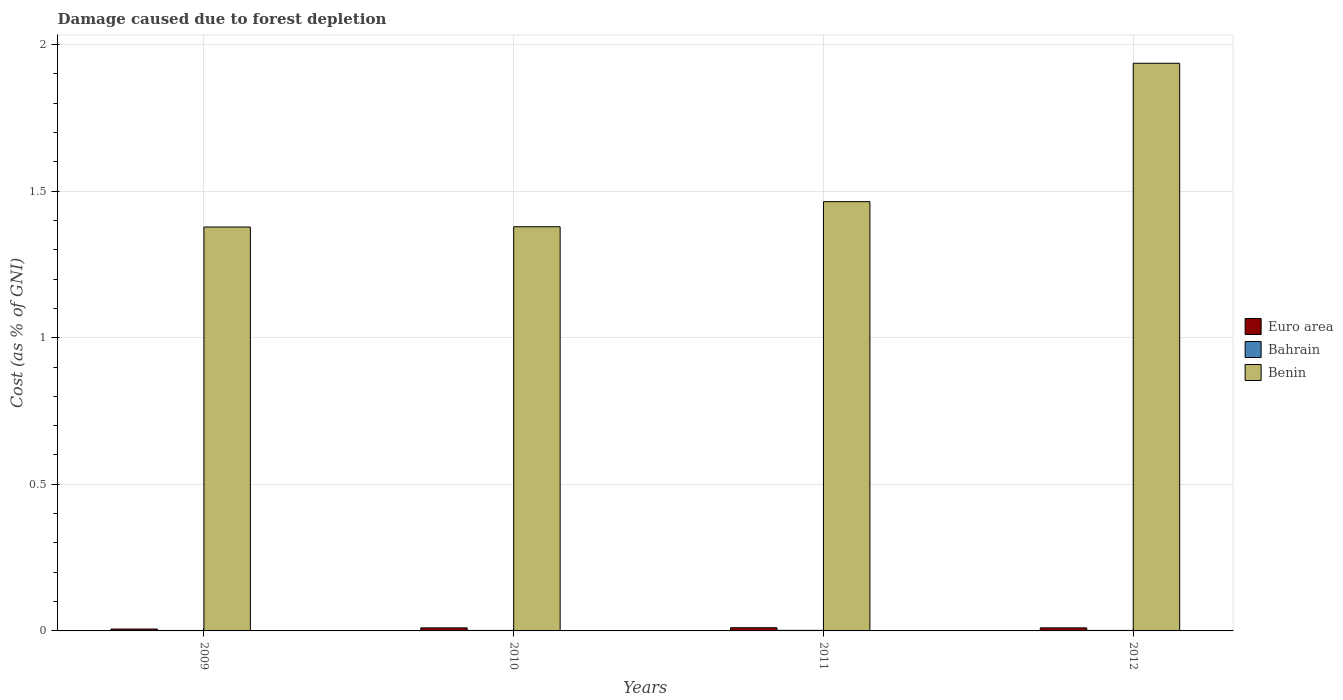How many different coloured bars are there?
Give a very brief answer. 3. How many groups of bars are there?
Your answer should be compact. 4. What is the label of the 2nd group of bars from the left?
Provide a short and direct response. 2010. What is the cost of damage caused due to forest depletion in Euro area in 2012?
Your answer should be compact. 0.01. Across all years, what is the maximum cost of damage caused due to forest depletion in Benin?
Provide a succinct answer. 1.94. Across all years, what is the minimum cost of damage caused due to forest depletion in Euro area?
Your answer should be very brief. 0.01. In which year was the cost of damage caused due to forest depletion in Euro area minimum?
Provide a succinct answer. 2009. What is the total cost of damage caused due to forest depletion in Euro area in the graph?
Your answer should be very brief. 0.04. What is the difference between the cost of damage caused due to forest depletion in Benin in 2009 and that in 2012?
Provide a short and direct response. -0.56. What is the difference between the cost of damage caused due to forest depletion in Benin in 2011 and the cost of damage caused due to forest depletion in Euro area in 2009?
Offer a very short reply. 1.46. What is the average cost of damage caused due to forest depletion in Bahrain per year?
Offer a terse response. 0. In the year 2012, what is the difference between the cost of damage caused due to forest depletion in Euro area and cost of damage caused due to forest depletion in Benin?
Make the answer very short. -1.93. In how many years, is the cost of damage caused due to forest depletion in Euro area greater than 1.6 %?
Offer a terse response. 0. What is the ratio of the cost of damage caused due to forest depletion in Benin in 2010 to that in 2012?
Give a very brief answer. 0.71. Is the difference between the cost of damage caused due to forest depletion in Euro area in 2011 and 2012 greater than the difference between the cost of damage caused due to forest depletion in Benin in 2011 and 2012?
Give a very brief answer. Yes. What is the difference between the highest and the second highest cost of damage caused due to forest depletion in Bahrain?
Provide a short and direct response. 0. What is the difference between the highest and the lowest cost of damage caused due to forest depletion in Bahrain?
Your answer should be compact. 0. What does the 2nd bar from the left in 2009 represents?
Keep it short and to the point. Bahrain. What does the 2nd bar from the right in 2011 represents?
Provide a succinct answer. Bahrain. Are the values on the major ticks of Y-axis written in scientific E-notation?
Your answer should be very brief. No. How many legend labels are there?
Offer a very short reply. 3. How are the legend labels stacked?
Ensure brevity in your answer.  Vertical. What is the title of the graph?
Provide a succinct answer. Damage caused due to forest depletion. Does "Jordan" appear as one of the legend labels in the graph?
Your answer should be compact. No. What is the label or title of the Y-axis?
Provide a succinct answer. Cost (as % of GNI). What is the Cost (as % of GNI) of Euro area in 2009?
Your answer should be very brief. 0.01. What is the Cost (as % of GNI) in Bahrain in 2009?
Provide a succinct answer. 0. What is the Cost (as % of GNI) in Benin in 2009?
Provide a succinct answer. 1.38. What is the Cost (as % of GNI) of Euro area in 2010?
Give a very brief answer. 0.01. What is the Cost (as % of GNI) in Bahrain in 2010?
Provide a succinct answer. 0. What is the Cost (as % of GNI) in Benin in 2010?
Ensure brevity in your answer.  1.38. What is the Cost (as % of GNI) in Euro area in 2011?
Your response must be concise. 0.01. What is the Cost (as % of GNI) of Bahrain in 2011?
Ensure brevity in your answer.  0. What is the Cost (as % of GNI) in Benin in 2011?
Provide a short and direct response. 1.46. What is the Cost (as % of GNI) in Euro area in 2012?
Give a very brief answer. 0.01. What is the Cost (as % of GNI) in Bahrain in 2012?
Your response must be concise. 0. What is the Cost (as % of GNI) of Benin in 2012?
Give a very brief answer. 1.94. Across all years, what is the maximum Cost (as % of GNI) in Euro area?
Provide a succinct answer. 0.01. Across all years, what is the maximum Cost (as % of GNI) in Bahrain?
Your answer should be compact. 0. Across all years, what is the maximum Cost (as % of GNI) in Benin?
Your answer should be very brief. 1.94. Across all years, what is the minimum Cost (as % of GNI) in Euro area?
Your answer should be very brief. 0.01. Across all years, what is the minimum Cost (as % of GNI) in Bahrain?
Make the answer very short. 0. Across all years, what is the minimum Cost (as % of GNI) in Benin?
Offer a very short reply. 1.38. What is the total Cost (as % of GNI) in Euro area in the graph?
Your answer should be compact. 0.04. What is the total Cost (as % of GNI) of Bahrain in the graph?
Give a very brief answer. 0.01. What is the total Cost (as % of GNI) of Benin in the graph?
Provide a short and direct response. 6.16. What is the difference between the Cost (as % of GNI) of Euro area in 2009 and that in 2010?
Provide a succinct answer. -0. What is the difference between the Cost (as % of GNI) of Bahrain in 2009 and that in 2010?
Offer a very short reply. -0. What is the difference between the Cost (as % of GNI) in Benin in 2009 and that in 2010?
Keep it short and to the point. -0. What is the difference between the Cost (as % of GNI) of Euro area in 2009 and that in 2011?
Ensure brevity in your answer.  -0. What is the difference between the Cost (as % of GNI) in Bahrain in 2009 and that in 2011?
Keep it short and to the point. -0. What is the difference between the Cost (as % of GNI) in Benin in 2009 and that in 2011?
Offer a very short reply. -0.09. What is the difference between the Cost (as % of GNI) of Euro area in 2009 and that in 2012?
Your answer should be compact. -0. What is the difference between the Cost (as % of GNI) in Bahrain in 2009 and that in 2012?
Give a very brief answer. -0. What is the difference between the Cost (as % of GNI) of Benin in 2009 and that in 2012?
Offer a terse response. -0.56. What is the difference between the Cost (as % of GNI) of Euro area in 2010 and that in 2011?
Offer a very short reply. -0. What is the difference between the Cost (as % of GNI) in Bahrain in 2010 and that in 2011?
Provide a short and direct response. -0. What is the difference between the Cost (as % of GNI) in Benin in 2010 and that in 2011?
Your answer should be compact. -0.09. What is the difference between the Cost (as % of GNI) of Euro area in 2010 and that in 2012?
Your answer should be compact. -0. What is the difference between the Cost (as % of GNI) in Bahrain in 2010 and that in 2012?
Provide a short and direct response. 0. What is the difference between the Cost (as % of GNI) in Benin in 2010 and that in 2012?
Your response must be concise. -0.56. What is the difference between the Cost (as % of GNI) in Bahrain in 2011 and that in 2012?
Your response must be concise. 0. What is the difference between the Cost (as % of GNI) in Benin in 2011 and that in 2012?
Provide a short and direct response. -0.47. What is the difference between the Cost (as % of GNI) of Euro area in 2009 and the Cost (as % of GNI) of Bahrain in 2010?
Give a very brief answer. 0. What is the difference between the Cost (as % of GNI) of Euro area in 2009 and the Cost (as % of GNI) of Benin in 2010?
Provide a succinct answer. -1.37. What is the difference between the Cost (as % of GNI) of Bahrain in 2009 and the Cost (as % of GNI) of Benin in 2010?
Your answer should be very brief. -1.38. What is the difference between the Cost (as % of GNI) of Euro area in 2009 and the Cost (as % of GNI) of Bahrain in 2011?
Make the answer very short. 0. What is the difference between the Cost (as % of GNI) in Euro area in 2009 and the Cost (as % of GNI) in Benin in 2011?
Your answer should be compact. -1.46. What is the difference between the Cost (as % of GNI) of Bahrain in 2009 and the Cost (as % of GNI) of Benin in 2011?
Make the answer very short. -1.46. What is the difference between the Cost (as % of GNI) of Euro area in 2009 and the Cost (as % of GNI) of Bahrain in 2012?
Provide a short and direct response. 0. What is the difference between the Cost (as % of GNI) of Euro area in 2009 and the Cost (as % of GNI) of Benin in 2012?
Offer a very short reply. -1.93. What is the difference between the Cost (as % of GNI) in Bahrain in 2009 and the Cost (as % of GNI) in Benin in 2012?
Your answer should be compact. -1.93. What is the difference between the Cost (as % of GNI) in Euro area in 2010 and the Cost (as % of GNI) in Bahrain in 2011?
Make the answer very short. 0.01. What is the difference between the Cost (as % of GNI) of Euro area in 2010 and the Cost (as % of GNI) of Benin in 2011?
Your answer should be very brief. -1.45. What is the difference between the Cost (as % of GNI) of Bahrain in 2010 and the Cost (as % of GNI) of Benin in 2011?
Provide a short and direct response. -1.46. What is the difference between the Cost (as % of GNI) in Euro area in 2010 and the Cost (as % of GNI) in Bahrain in 2012?
Give a very brief answer. 0.01. What is the difference between the Cost (as % of GNI) in Euro area in 2010 and the Cost (as % of GNI) in Benin in 2012?
Your response must be concise. -1.93. What is the difference between the Cost (as % of GNI) in Bahrain in 2010 and the Cost (as % of GNI) in Benin in 2012?
Provide a short and direct response. -1.93. What is the difference between the Cost (as % of GNI) of Euro area in 2011 and the Cost (as % of GNI) of Bahrain in 2012?
Provide a short and direct response. 0.01. What is the difference between the Cost (as % of GNI) of Euro area in 2011 and the Cost (as % of GNI) of Benin in 2012?
Make the answer very short. -1.93. What is the difference between the Cost (as % of GNI) in Bahrain in 2011 and the Cost (as % of GNI) in Benin in 2012?
Provide a short and direct response. -1.93. What is the average Cost (as % of GNI) in Euro area per year?
Your response must be concise. 0.01. What is the average Cost (as % of GNI) in Bahrain per year?
Provide a succinct answer. 0. What is the average Cost (as % of GNI) in Benin per year?
Your answer should be compact. 1.54. In the year 2009, what is the difference between the Cost (as % of GNI) in Euro area and Cost (as % of GNI) in Bahrain?
Your response must be concise. 0. In the year 2009, what is the difference between the Cost (as % of GNI) of Euro area and Cost (as % of GNI) of Benin?
Make the answer very short. -1.37. In the year 2009, what is the difference between the Cost (as % of GNI) of Bahrain and Cost (as % of GNI) of Benin?
Make the answer very short. -1.38. In the year 2010, what is the difference between the Cost (as % of GNI) in Euro area and Cost (as % of GNI) in Bahrain?
Give a very brief answer. 0.01. In the year 2010, what is the difference between the Cost (as % of GNI) of Euro area and Cost (as % of GNI) of Benin?
Offer a terse response. -1.37. In the year 2010, what is the difference between the Cost (as % of GNI) of Bahrain and Cost (as % of GNI) of Benin?
Offer a very short reply. -1.38. In the year 2011, what is the difference between the Cost (as % of GNI) in Euro area and Cost (as % of GNI) in Bahrain?
Your response must be concise. 0.01. In the year 2011, what is the difference between the Cost (as % of GNI) of Euro area and Cost (as % of GNI) of Benin?
Give a very brief answer. -1.45. In the year 2011, what is the difference between the Cost (as % of GNI) in Bahrain and Cost (as % of GNI) in Benin?
Provide a short and direct response. -1.46. In the year 2012, what is the difference between the Cost (as % of GNI) in Euro area and Cost (as % of GNI) in Bahrain?
Your answer should be compact. 0.01. In the year 2012, what is the difference between the Cost (as % of GNI) in Euro area and Cost (as % of GNI) in Benin?
Your response must be concise. -1.93. In the year 2012, what is the difference between the Cost (as % of GNI) of Bahrain and Cost (as % of GNI) of Benin?
Provide a short and direct response. -1.93. What is the ratio of the Cost (as % of GNI) of Euro area in 2009 to that in 2010?
Provide a succinct answer. 0.62. What is the ratio of the Cost (as % of GNI) of Bahrain in 2009 to that in 2010?
Your answer should be compact. 0.89. What is the ratio of the Cost (as % of GNI) in Euro area in 2009 to that in 2011?
Your answer should be compact. 0.59. What is the ratio of the Cost (as % of GNI) of Bahrain in 2009 to that in 2011?
Provide a succinct answer. 0.82. What is the ratio of the Cost (as % of GNI) of Benin in 2009 to that in 2011?
Make the answer very short. 0.94. What is the ratio of the Cost (as % of GNI) in Euro area in 2009 to that in 2012?
Provide a succinct answer. 0.62. What is the ratio of the Cost (as % of GNI) in Bahrain in 2009 to that in 2012?
Offer a terse response. 0.9. What is the ratio of the Cost (as % of GNI) in Benin in 2009 to that in 2012?
Make the answer very short. 0.71. What is the ratio of the Cost (as % of GNI) in Euro area in 2010 to that in 2011?
Your answer should be very brief. 0.95. What is the ratio of the Cost (as % of GNI) of Bahrain in 2010 to that in 2011?
Your answer should be very brief. 0.92. What is the ratio of the Cost (as % of GNI) in Benin in 2010 to that in 2011?
Your answer should be very brief. 0.94. What is the ratio of the Cost (as % of GNI) in Bahrain in 2010 to that in 2012?
Ensure brevity in your answer.  1.01. What is the ratio of the Cost (as % of GNI) in Benin in 2010 to that in 2012?
Keep it short and to the point. 0.71. What is the ratio of the Cost (as % of GNI) of Euro area in 2011 to that in 2012?
Make the answer very short. 1.05. What is the ratio of the Cost (as % of GNI) in Bahrain in 2011 to that in 2012?
Keep it short and to the point. 1.09. What is the ratio of the Cost (as % of GNI) in Benin in 2011 to that in 2012?
Give a very brief answer. 0.76. What is the difference between the highest and the second highest Cost (as % of GNI) of Benin?
Give a very brief answer. 0.47. What is the difference between the highest and the lowest Cost (as % of GNI) of Euro area?
Offer a very short reply. 0. What is the difference between the highest and the lowest Cost (as % of GNI) in Benin?
Your response must be concise. 0.56. 